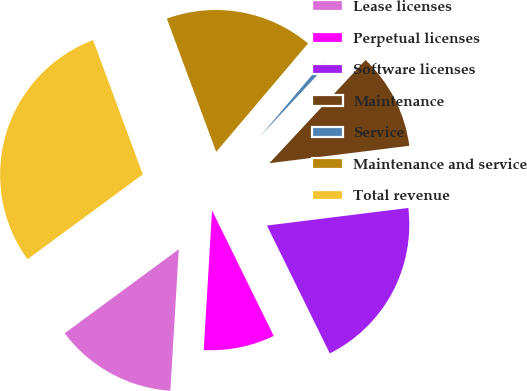Convert chart. <chart><loc_0><loc_0><loc_500><loc_500><pie_chart><fcel>Lease licenses<fcel>Perpetual licenses<fcel>Software licenses<fcel>Maintenance<fcel>Service<fcel>Maintenance and service<fcel>Total revenue<nl><fcel>13.96%<fcel>8.22%<fcel>19.7%<fcel>11.09%<fcel>0.76%<fcel>16.83%<fcel>29.46%<nl></chart> 